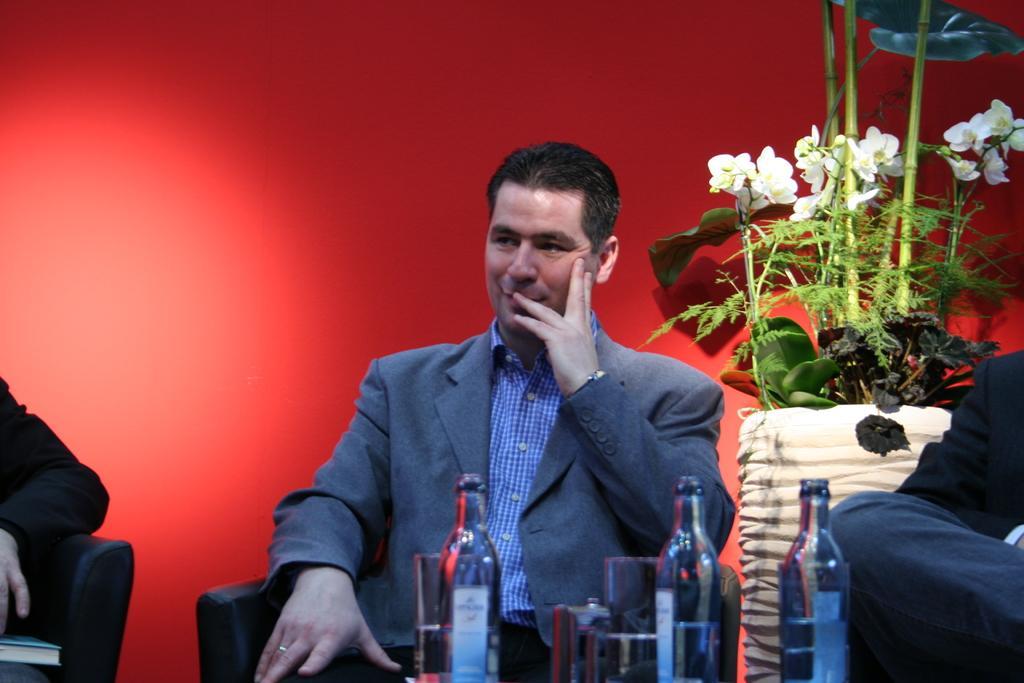In one or two sentences, can you explain what this image depicts? In this picture I can see a person wearing the coat and sitting on the chair. I can see the bottles and glasses in the foreground. I can see the plant vase on the right side. 